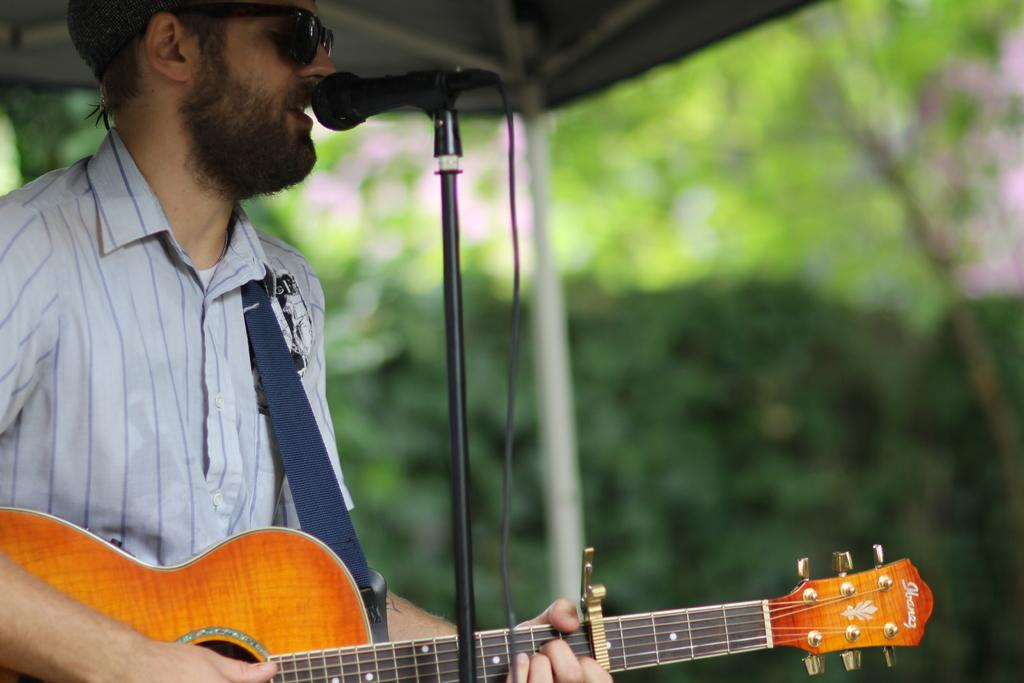What is the man in the image doing? The man is playing a guitar, singing, and using a microphone. What is the man's posture in the image? The man is standing in the image. What can be seen in the background of the image? There are trees visible in the image. Can you see any islands in the image? There are no islands visible in the image. What type of ant is crawling on the man's guitar in the image? There are no ants present in the image, let alone crawling on the guitar. 